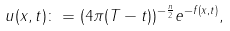Convert formula to latex. <formula><loc_0><loc_0><loc_500><loc_500>u ( x , t ) \colon = ( 4 \pi ( T - t ) ) ^ { - \frac { n } { 2 } } e ^ { - f ( x , t ) } ,</formula> 